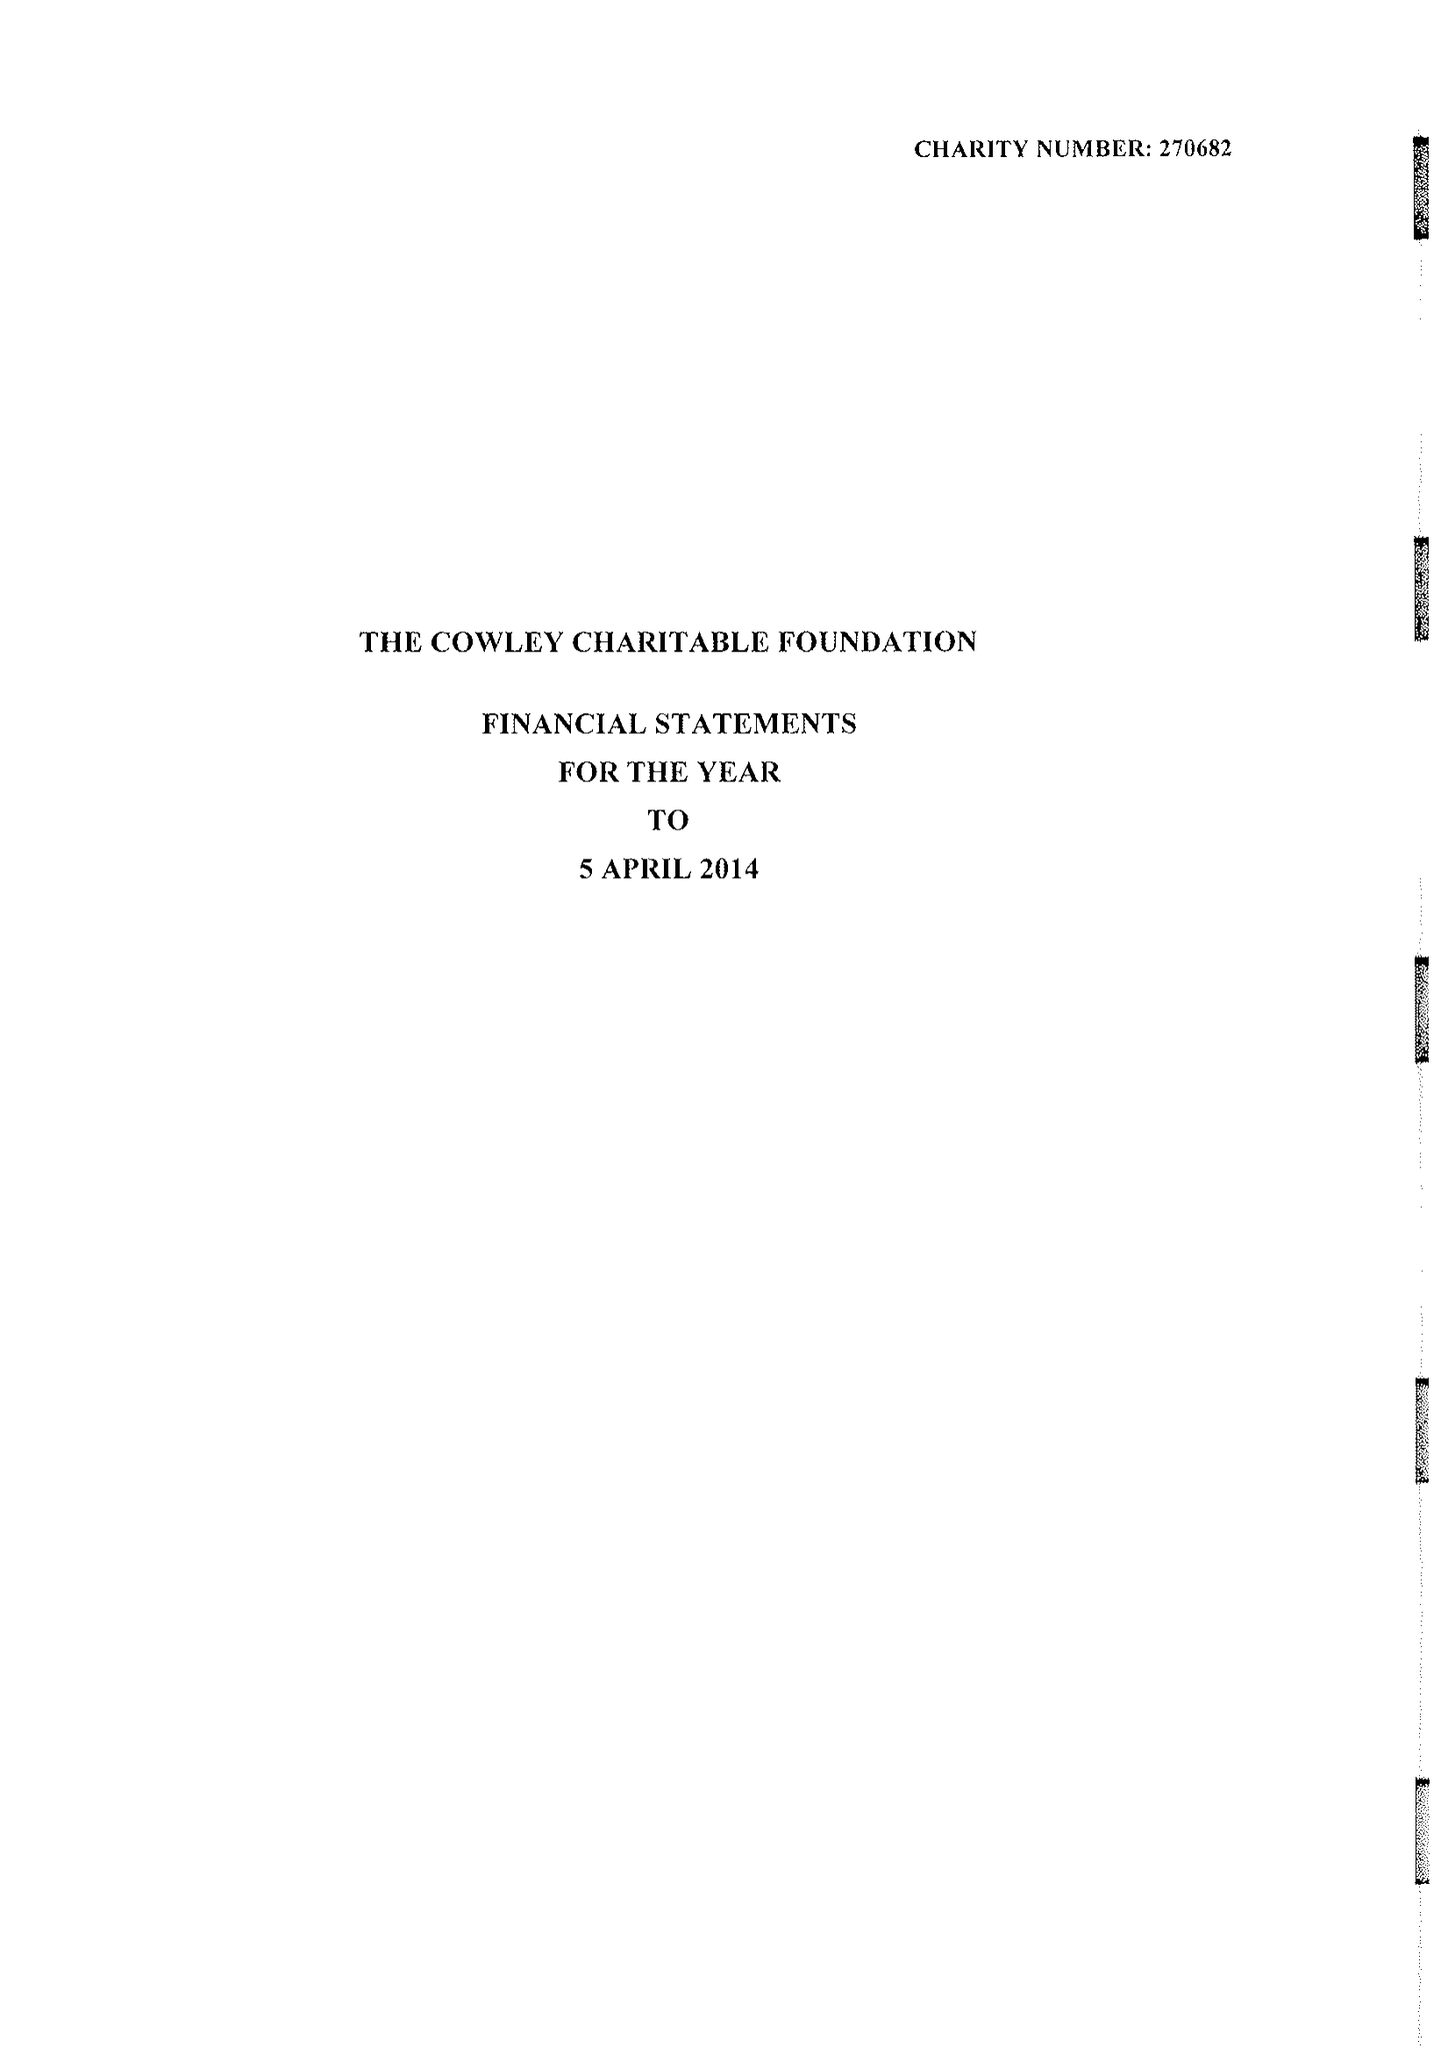What is the value for the report_date?
Answer the question using a single word or phrase. 2014-04-05 